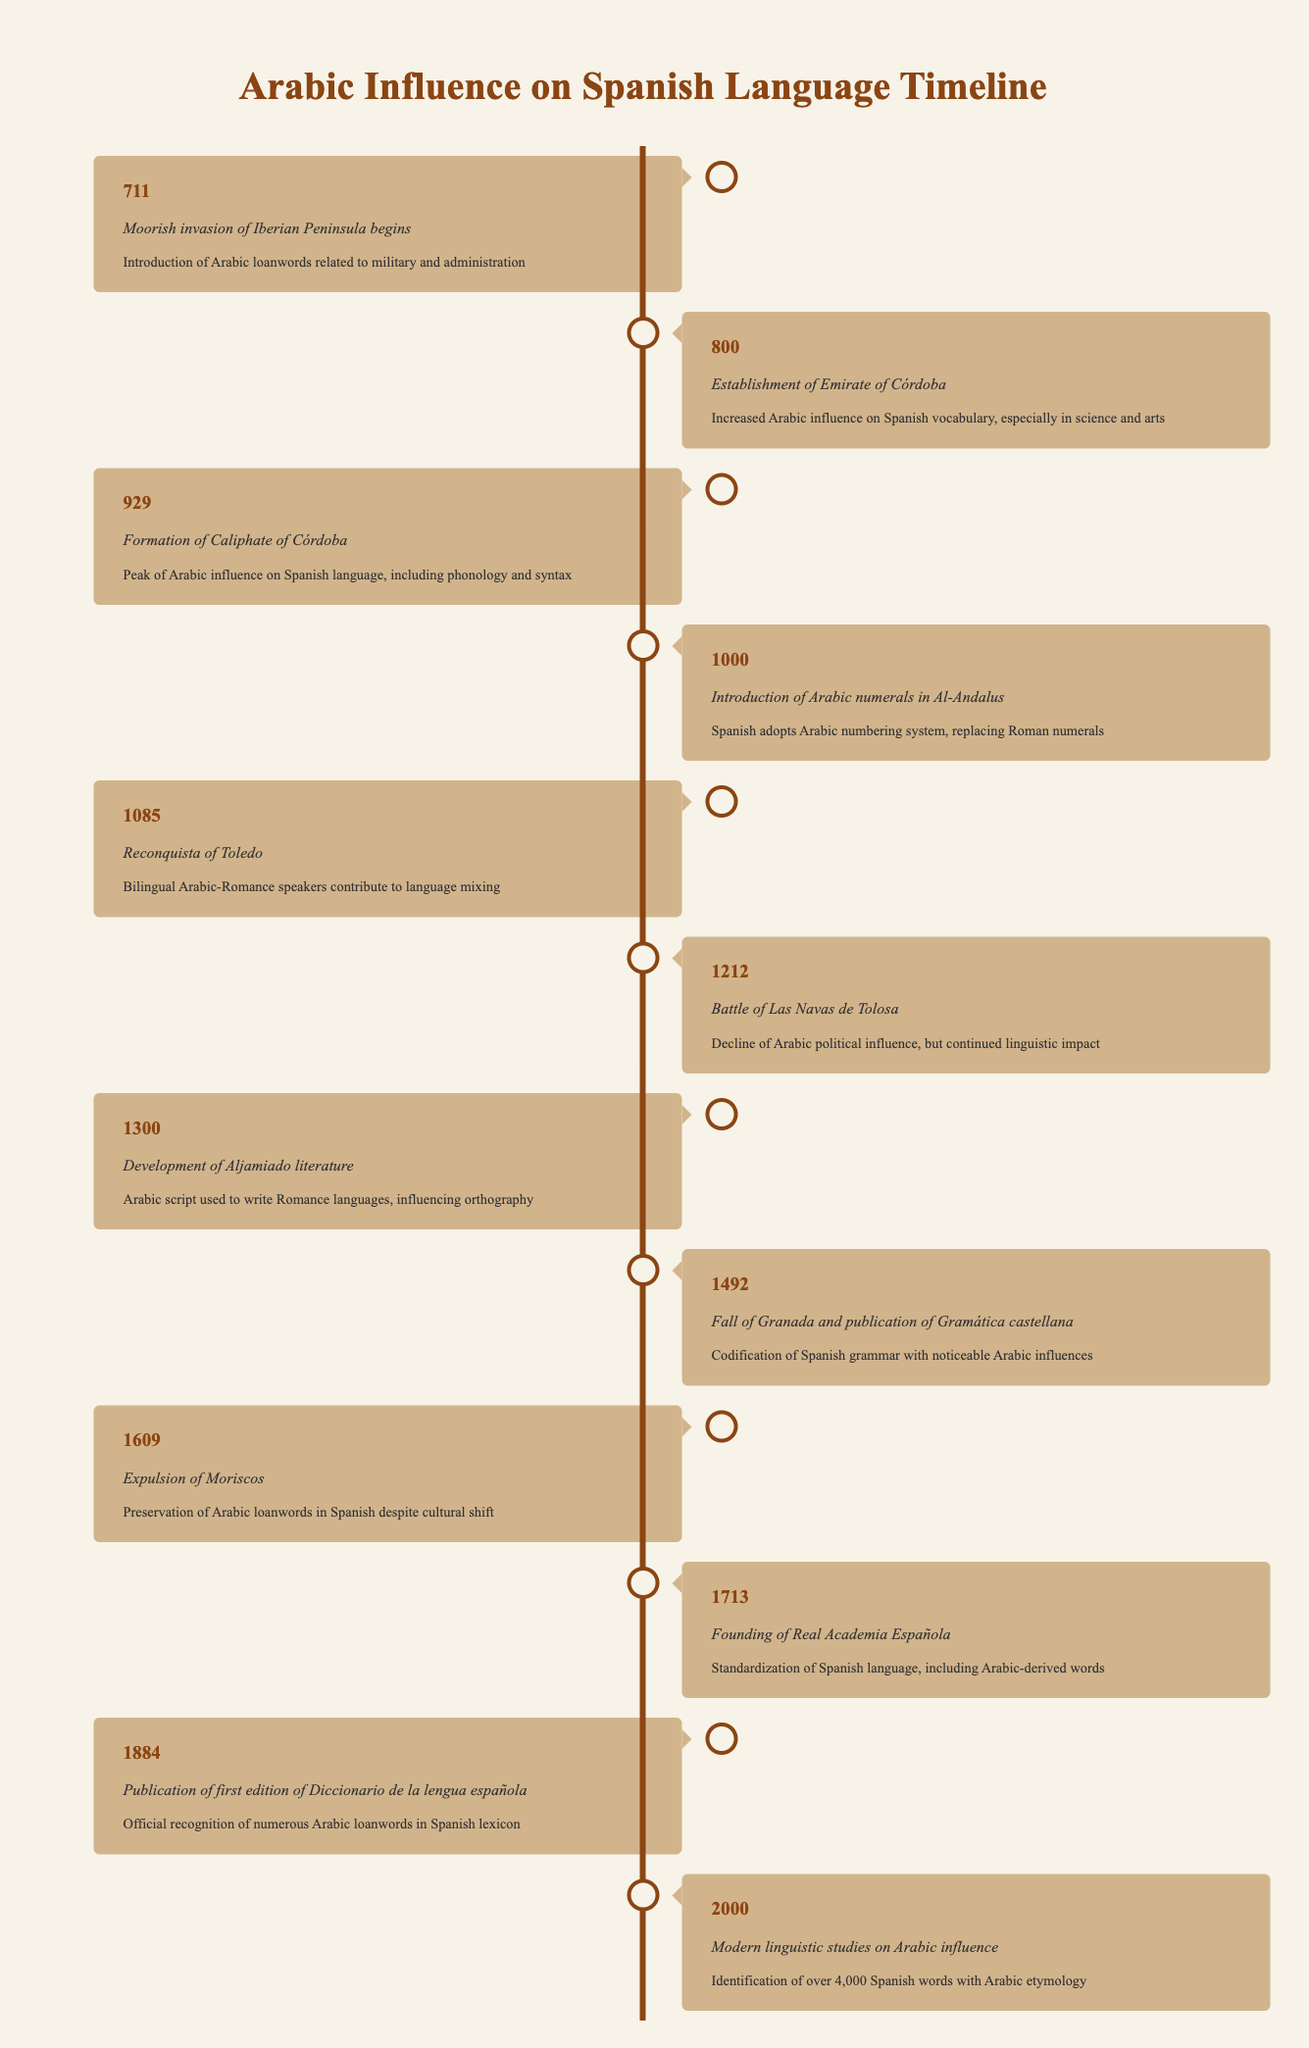What event marked the peak of Arabic influence on the Spanish language? According to the timeline, the event that marks the peak of Arabic influence on the Spanish language is the formation of the Caliphate of Córdoba in the year 929.
Answer: Formation of Caliphate of Córdoba What was the impact of the Battle of Las Navas de Tolosa in 1212? The timeline indicates that the impact of the Battle of Las Navas de Tolosa was a decline of Arabic political influence, although the linguistic impact continued.
Answer: Decline of Arabic political influence, continued linguistic impact How many years were there between the Moorish invasion and the establishment of the Emirate of Córdoba? The Moorish invasion began in 711 and the Emirate of Córdoba was established in 800. Thus, the difference is 800 - 711 = 89 years.
Answer: 89 years In what year did the expulsion of Moriscos take place? The timeline states that the expulsion of Moriscos occurred in 1609.
Answer: 1609 Was the introduction of Arabic numerals in Al-Andalus significant for Spanish language evolution? Yes, the introduction of Arabic numerals in the year 1000 significantly influenced the Spanish language by replacing Roman numerals.
Answer: Yes What is the total number of events related to Arabic influence that occurred in the 13th century? There are two events listed in the 13th century: the Battle of Las Navas de Tolosa in 1212 and the year for which modern studies on Arabic influence are recorded (2000 is in the 21st century). Thus, only one event is from the 13th century.
Answer: 1 event How did the founding of the Real Academia Española in 1713 contribute to the Spanish language? The founding of the Real Academia Española standardized the Spanish language, incorporating Arabic-derived words, which highlights its influence in linguistics.
Answer: Standardization of Spanish language What is the last event listed regarding Arabic influence on the Spanish language? The last event in the timeline regarding Arabic influence is the modern linguistic studies conducted in the year 2000.
Answer: Modern linguistic studies in 2000 What significant change occurred in 1492 regarding Spanish grammar? The timeline highlights that in 1492, the Fall of Granada coincided with the publication of Gramática castellana, which codified Spanish grammar with noticeable Arabic influences.
Answer: Codification of Spanish grammar with Arabic influences 